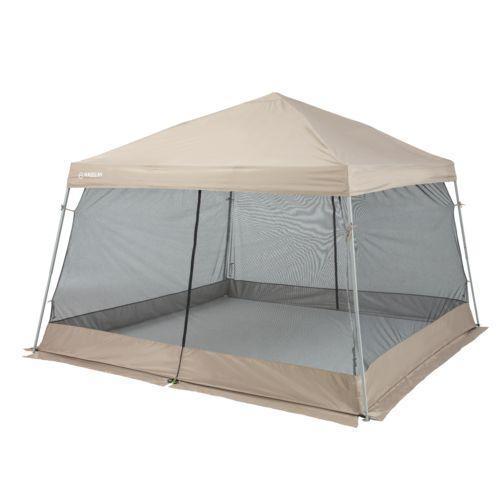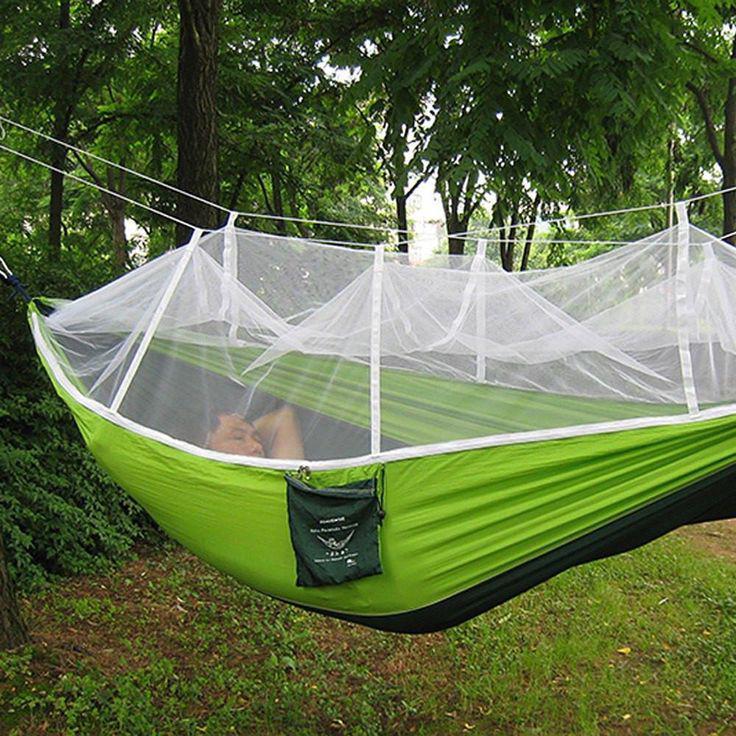The first image is the image on the left, the second image is the image on the right. Assess this claim about the two images: "There is grass visible on one of the images.". Correct or not? Answer yes or no. Yes. The first image is the image on the left, the second image is the image on the right. Given the left and right images, does the statement "there is a person in one of the images" hold true? Answer yes or no. Yes. 